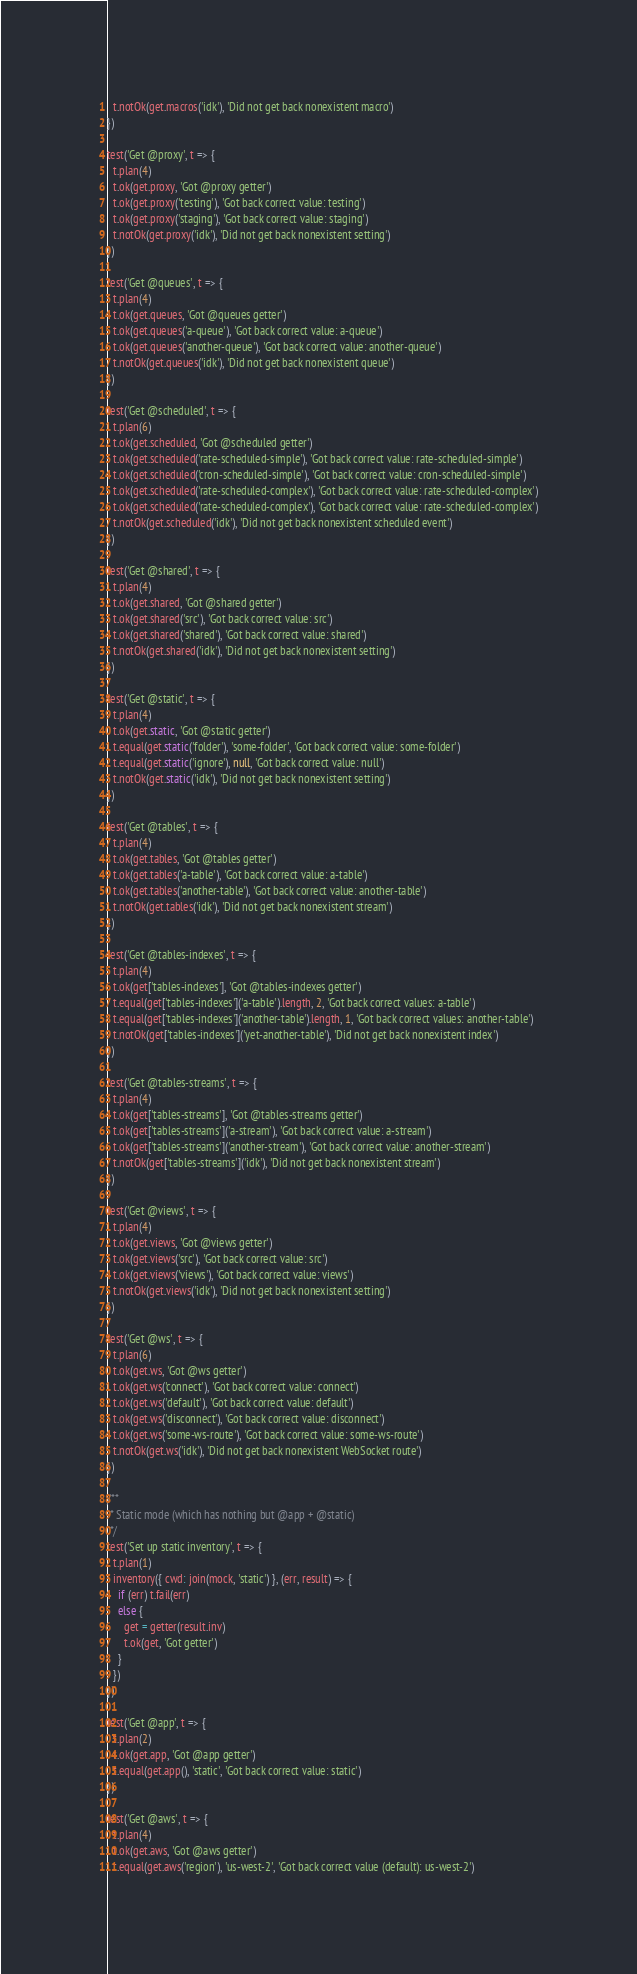Convert code to text. <code><loc_0><loc_0><loc_500><loc_500><_JavaScript_>  t.notOk(get.macros('idk'), 'Did not get back nonexistent macro')
})

test('Get @proxy', t => {
  t.plan(4)
  t.ok(get.proxy, 'Got @proxy getter')
  t.ok(get.proxy('testing'), 'Got back correct value: testing')
  t.ok(get.proxy('staging'), 'Got back correct value: staging')
  t.notOk(get.proxy('idk'), 'Did not get back nonexistent setting')
})

test('Get @queues', t => {
  t.plan(4)
  t.ok(get.queues, 'Got @queues getter')
  t.ok(get.queues('a-queue'), 'Got back correct value: a-queue')
  t.ok(get.queues('another-queue'), 'Got back correct value: another-queue')
  t.notOk(get.queues('idk'), 'Did not get back nonexistent queue')
})

test('Get @scheduled', t => {
  t.plan(6)
  t.ok(get.scheduled, 'Got @scheduled getter')
  t.ok(get.scheduled('rate-scheduled-simple'), 'Got back correct value: rate-scheduled-simple')
  t.ok(get.scheduled('cron-scheduled-simple'), 'Got back correct value: cron-scheduled-simple')
  t.ok(get.scheduled('rate-scheduled-complex'), 'Got back correct value: rate-scheduled-complex')
  t.ok(get.scheduled('rate-scheduled-complex'), 'Got back correct value: rate-scheduled-complex')
  t.notOk(get.scheduled('idk'), 'Did not get back nonexistent scheduled event')
})

test('Get @shared', t => {
  t.plan(4)
  t.ok(get.shared, 'Got @shared getter')
  t.ok(get.shared('src'), 'Got back correct value: src')
  t.ok(get.shared('shared'), 'Got back correct value: shared')
  t.notOk(get.shared('idk'), 'Did not get back nonexistent setting')
})

test('Get @static', t => {
  t.plan(4)
  t.ok(get.static, 'Got @static getter')
  t.equal(get.static('folder'), 'some-folder', 'Got back correct value: some-folder')
  t.equal(get.static('ignore'), null, 'Got back correct value: null')
  t.notOk(get.static('idk'), 'Did not get back nonexistent setting')
})

test('Get @tables', t => {
  t.plan(4)
  t.ok(get.tables, 'Got @tables getter')
  t.ok(get.tables('a-table'), 'Got back correct value: a-table')
  t.ok(get.tables('another-table'), 'Got back correct value: another-table')
  t.notOk(get.tables('idk'), 'Did not get back nonexistent stream')
})

test('Get @tables-indexes', t => {
  t.plan(4)
  t.ok(get['tables-indexes'], 'Got @tables-indexes getter')
  t.equal(get['tables-indexes']('a-table').length, 2, 'Got back correct values: a-table')
  t.equal(get['tables-indexes']('another-table').length, 1, 'Got back correct values: another-table')
  t.notOk(get['tables-indexes']('yet-another-table'), 'Did not get back nonexistent index')
})

test('Get @tables-streams', t => {
  t.plan(4)
  t.ok(get['tables-streams'], 'Got @tables-streams getter')
  t.ok(get['tables-streams']('a-stream'), 'Got back correct value: a-stream')
  t.ok(get['tables-streams']('another-stream'), 'Got back correct value: another-stream')
  t.notOk(get['tables-streams']('idk'), 'Did not get back nonexistent stream')
})

test('Get @views', t => {
  t.plan(4)
  t.ok(get.views, 'Got @views getter')
  t.ok(get.views('src'), 'Got back correct value: src')
  t.ok(get.views('views'), 'Got back correct value: views')
  t.notOk(get.views('idk'), 'Did not get back nonexistent setting')
})

test('Get @ws', t => {
  t.plan(6)
  t.ok(get.ws, 'Got @ws getter')
  t.ok(get.ws('connect'), 'Got back correct value: connect')
  t.ok(get.ws('default'), 'Got back correct value: default')
  t.ok(get.ws('disconnect'), 'Got back correct value: disconnect')
  t.ok(get.ws('some-ws-route'), 'Got back correct value: some-ws-route')
  t.notOk(get.ws('idk'), 'Did not get back nonexistent WebSocket route')
})

/**
 * Static mode (which has nothing but @app + @static)
 */
test('Set up static inventory', t => {
  t.plan(1)
  inventory({ cwd: join(mock, 'static') }, (err, result) => {
    if (err) t.fail(err)
    else {
      get = getter(result.inv)
      t.ok(get, 'Got getter')
    }
  })
})

test('Get @app', t => {
  t.plan(2)
  t.ok(get.app, 'Got @app getter')
  t.equal(get.app(), 'static', 'Got back correct value: static')
})

test('Get @aws', t => {
  t.plan(4)
  t.ok(get.aws, 'Got @aws getter')
  t.equal(get.aws('region'), 'us-west-2', 'Got back correct value (default): us-west-2')</code> 